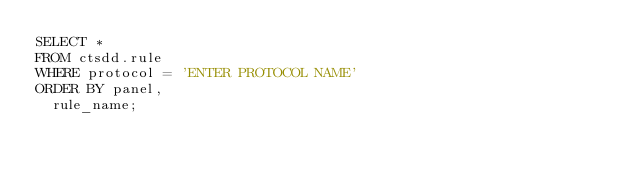<code> <loc_0><loc_0><loc_500><loc_500><_SQL_>SELECT *
FROM ctsdd.rule
WHERE protocol = 'ENTER PROTOCOL NAME'
ORDER BY panel,
  rule_name;
</code> 